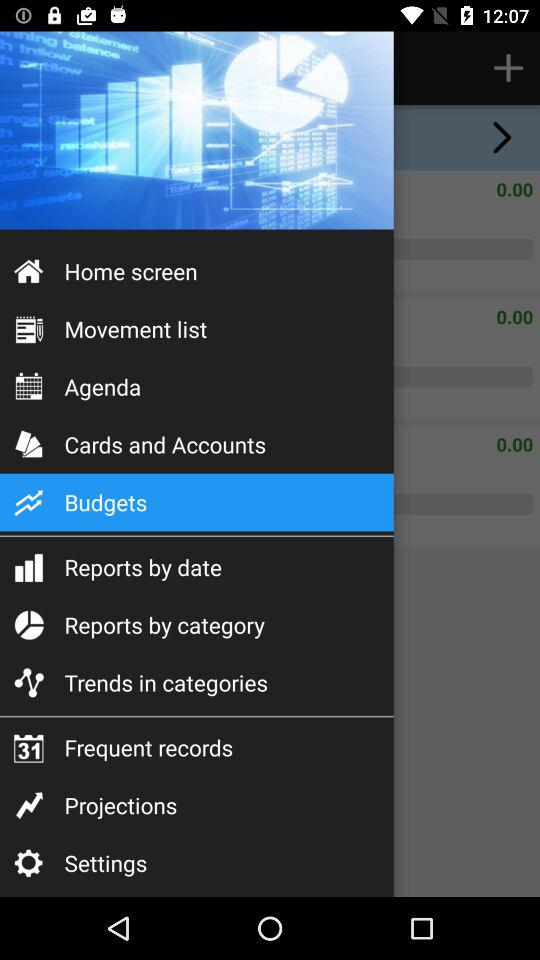Which item is selected? The selected item is "Budgets". 